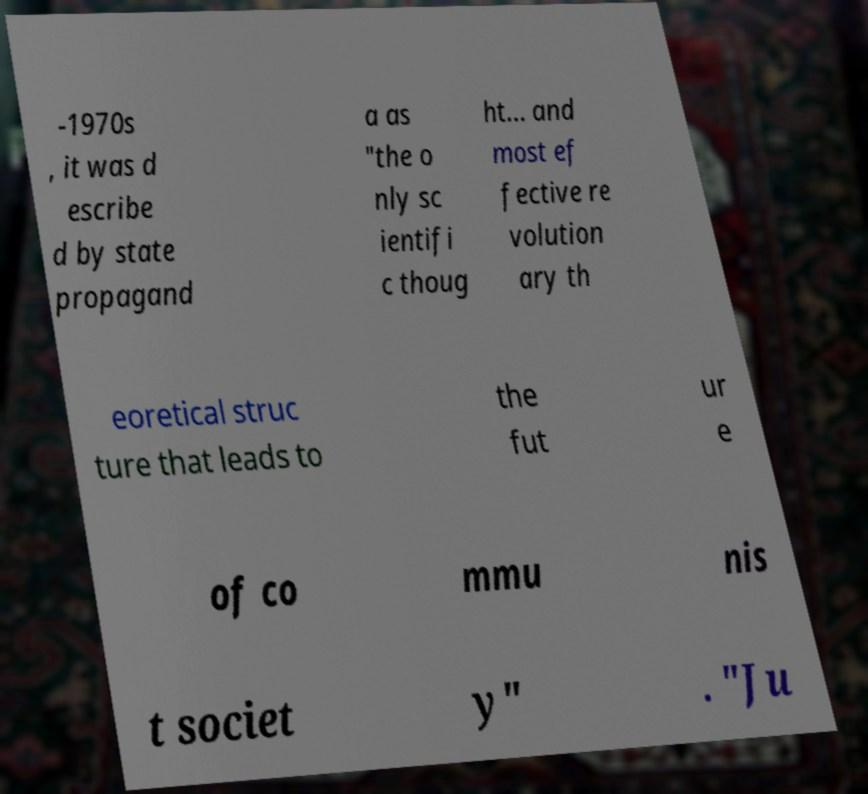Please identify and transcribe the text found in this image. -1970s , it was d escribe d by state propagand a as "the o nly sc ientifi c thoug ht... and most ef fective re volution ary th eoretical struc ture that leads to the fut ur e of co mmu nis t societ y" . "Ju 